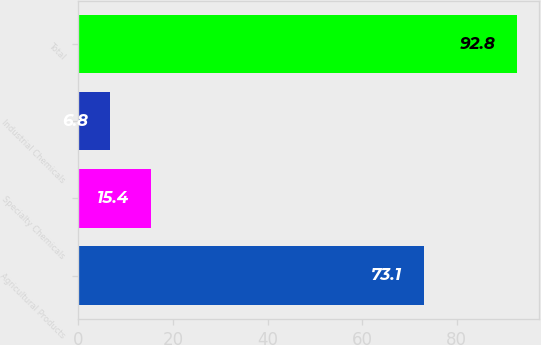Convert chart. <chart><loc_0><loc_0><loc_500><loc_500><bar_chart><fcel>Agricultural Products<fcel>Specialty Chemicals<fcel>Industrial Chemicals<fcel>Total<nl><fcel>73.1<fcel>15.4<fcel>6.8<fcel>92.8<nl></chart> 